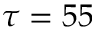<formula> <loc_0><loc_0><loc_500><loc_500>\tau = 5 5</formula> 